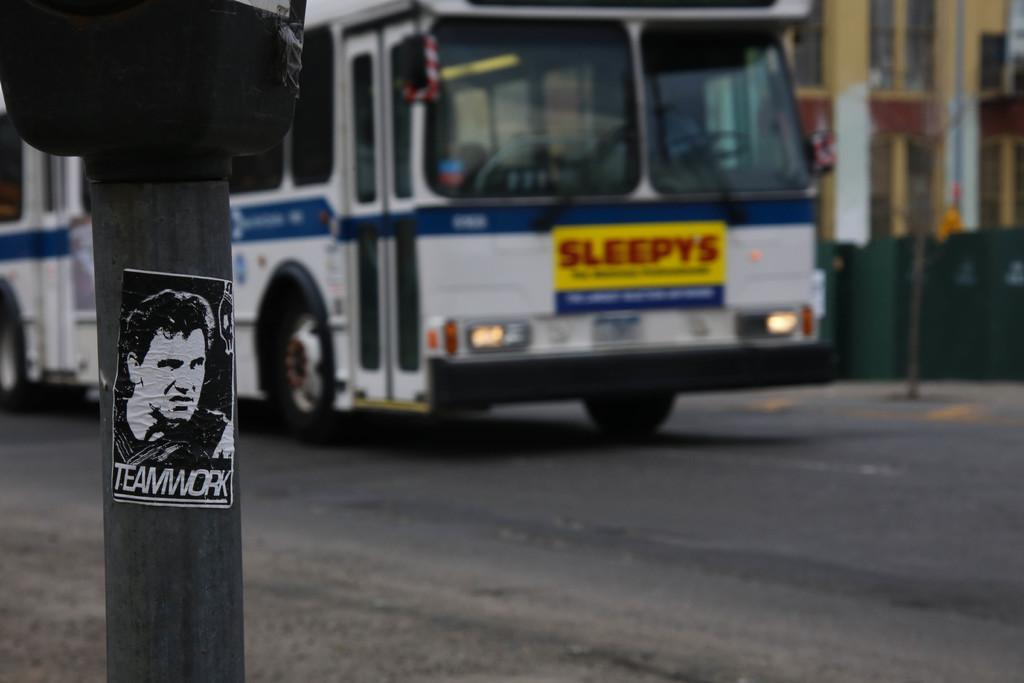What is the main object in the foreground of the image? There is a pole in the image. What can be seen in the background of the image? There is a bus, a road, and a building visible in the background of the image. How does the earthquake affect the pole in the image? There is no earthquake present in the image, so its effect on the pole cannot be determined. 